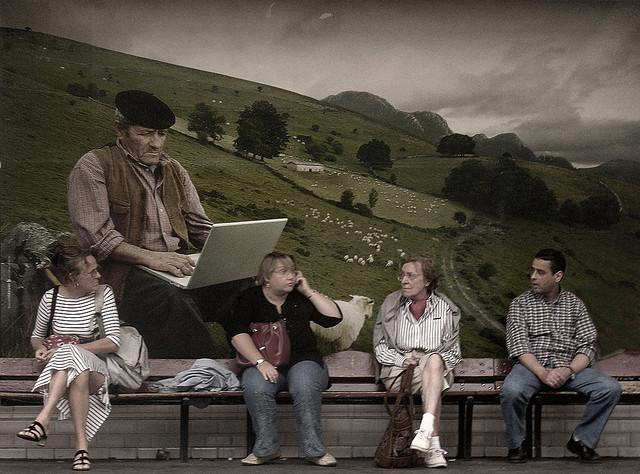What is the man in the mural using? Please explain your reasoning. laptop. The man is using a laptop. 